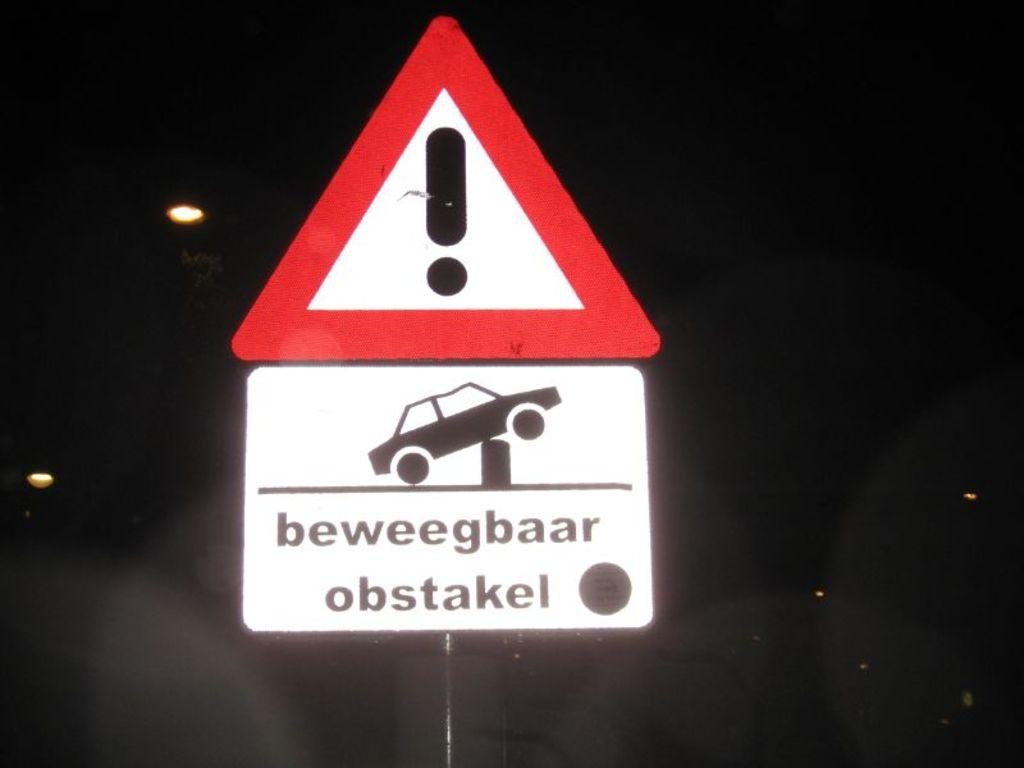What colors are the sign boards in the image? There is a white color sign board and a red color sign board in the image. What is depicted on the red color sign board? The red color sign board has a caution sign on it. What is the color of the background in the image? The background of the image is black in color. Can you describe any light sources visible in the image? Yes, there are lights visible in the image. How many houses are visible in the image? There are no houses visible in the image. What type of wing is attached to the sign board in the image? There is no wing attached to the sign board in the image. 